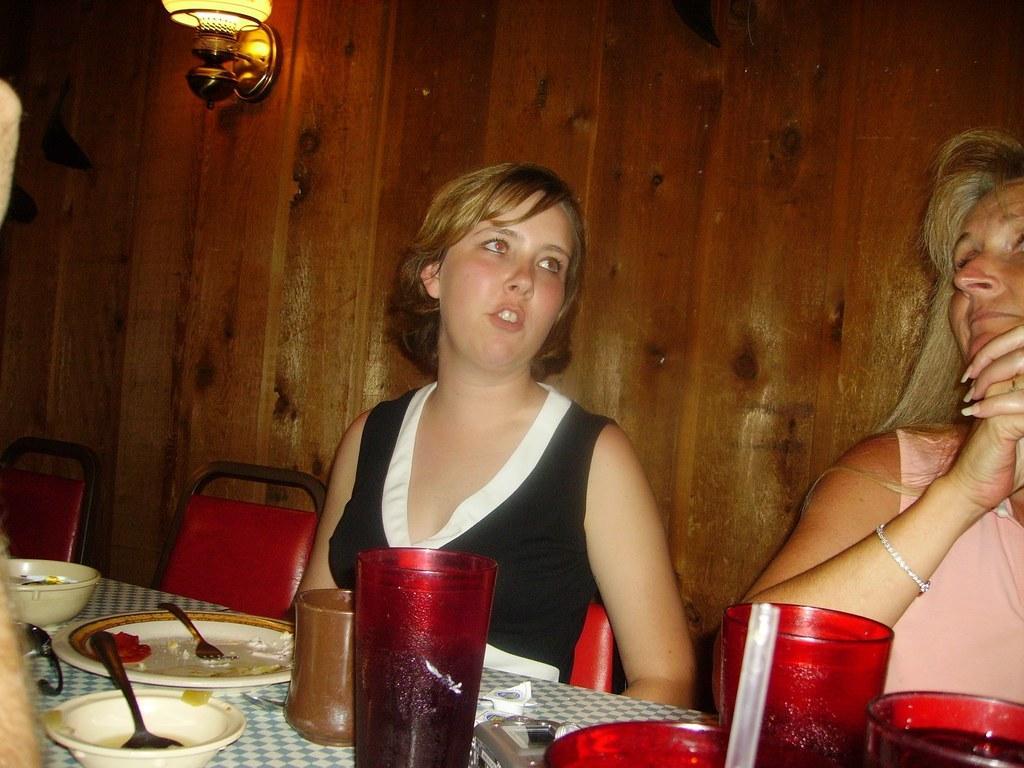In one or two sentences, can you explain what this image depicts? Two persons are sitting on a chairs. There is a table. There is a glass,bottle,plate,bowl ,spoon on a table. 